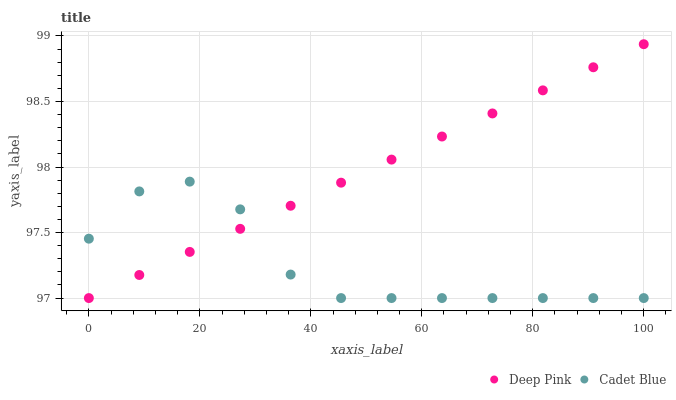Does Cadet Blue have the minimum area under the curve?
Answer yes or no. Yes. Does Deep Pink have the maximum area under the curve?
Answer yes or no. Yes. Does Deep Pink have the minimum area under the curve?
Answer yes or no. No. Is Deep Pink the smoothest?
Answer yes or no. Yes. Is Cadet Blue the roughest?
Answer yes or no. Yes. Is Deep Pink the roughest?
Answer yes or no. No. Does Cadet Blue have the lowest value?
Answer yes or no. Yes. Does Deep Pink have the highest value?
Answer yes or no. Yes. Does Cadet Blue intersect Deep Pink?
Answer yes or no. Yes. Is Cadet Blue less than Deep Pink?
Answer yes or no. No. Is Cadet Blue greater than Deep Pink?
Answer yes or no. No. 